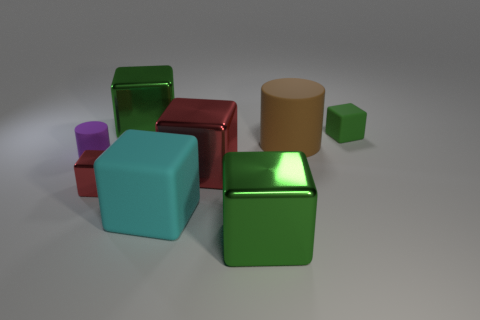How many green cubes must be subtracted to get 1 green cubes? 2 Subtract all purple cylinders. How many red blocks are left? 2 Subtract all green cubes. How many cubes are left? 3 Subtract all green metallic cubes. How many cubes are left? 4 Add 2 gray rubber things. How many objects exist? 10 Subtract all cylinders. How many objects are left? 6 Subtract all blue cubes. Subtract all brown balls. How many cubes are left? 6 Subtract 0 brown blocks. How many objects are left? 8 Subtract all big green shiny cubes. Subtract all tiny green things. How many objects are left? 5 Add 2 tiny red shiny cubes. How many tiny red shiny cubes are left? 3 